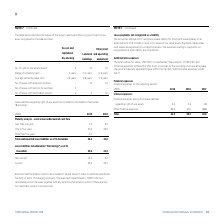According to Torm's financial document, In which year was the amount of other financial expenses the largest? According to the financial document, 2019. The relevant text states: "USDm 2019 2018 2017..." Also, can you calculate: What was the change in the total financial expenses in 2019 from 2018? Based on the calculation: 41.9-39.3, the result is 2.6 (in millions). This is based on the information: "Total 41.9 39.3 40.6 Total 41.9 39.3 40.6..." The key data points involved are: 39.3, 41.9. Also, can you calculate: What was the percentage change in the total financial expenses in 2019 from 2018? To answer this question, I need to perform calculations using the financial data. The calculation is: (41.9-39.3)/39.3, which equals 6.62 (percentage). This is based on the information: "Total 41.9 39.3 40.6 Total 41.9 39.3 40.6..." The key data points involved are: 39.3, 41.9. Also, What does the table show? Financial expenses for the reporting periods. The document states: "rative expenses” under IAS 17. Financial expenses Financial expenses for the reporting periods:..." Also, What is the total amount of financial expenses in 2019? According to the financial document, 41.9 (in millions). The relevant text states: "Total 41.9 39.3 40.6..." Also, What are the financial expenses under Interest Expenses in the table? The document shows two values: Financial expenses arising from lease liabilities regarding right-of-use assets and Other financial expenses. From the document: "Other financial expenses 39.5 37.0 38.8..." 